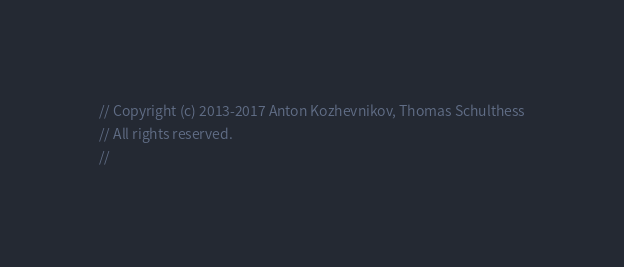<code> <loc_0><loc_0><loc_500><loc_500><_C++_>// Copyright (c) 2013-2017 Anton Kozhevnikov, Thomas Schulthess
// All rights reserved.
//</code> 